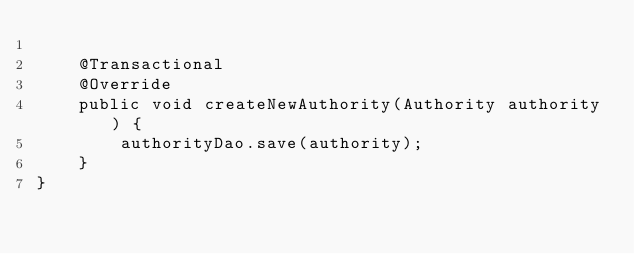Convert code to text. <code><loc_0><loc_0><loc_500><loc_500><_Java_>
    @Transactional
    @Override
    public void createNewAuthority(Authority authority) {
        authorityDao.save(authority);
    }
}
</code> 